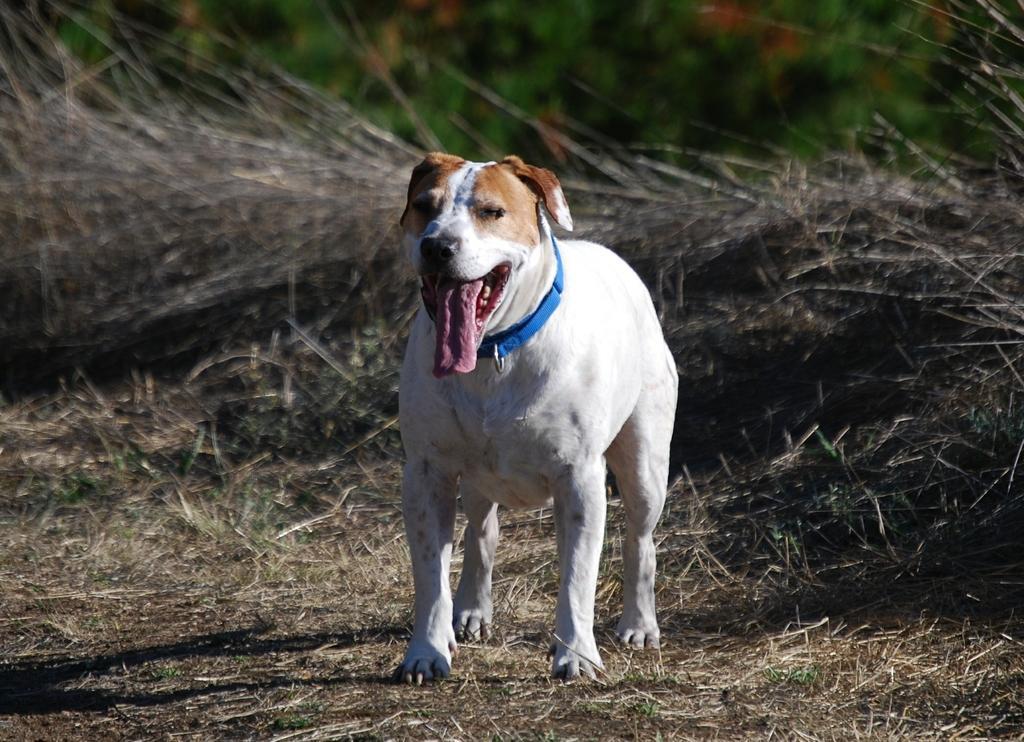Describe this image in one or two sentences. In the picture we can see a dried grass surface on it, we can see a dog is standing which is white in color with blue color belt in its neck and behind the dog we can see dried grass and behind it we can see some plants which are not clearly visible. 